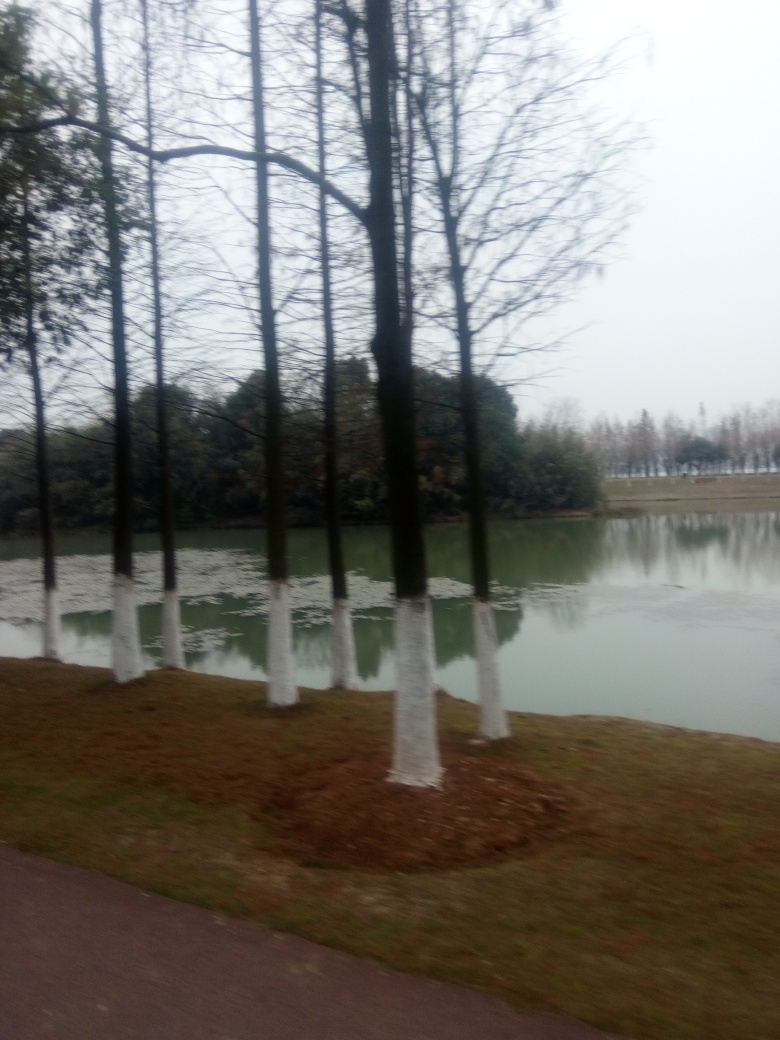What activities might be suitable for this setting? Given the open space, pathway, and serene backdrop of the water, activities like walking, jogging, or simply sitting and enjoying nature would be quite suitable for this setting. 